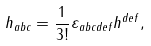Convert formula to latex. <formula><loc_0><loc_0><loc_500><loc_500>h _ { a b c } = \frac { 1 } { 3 ! } \varepsilon _ { a b c d e f } h ^ { d e f } ,</formula> 